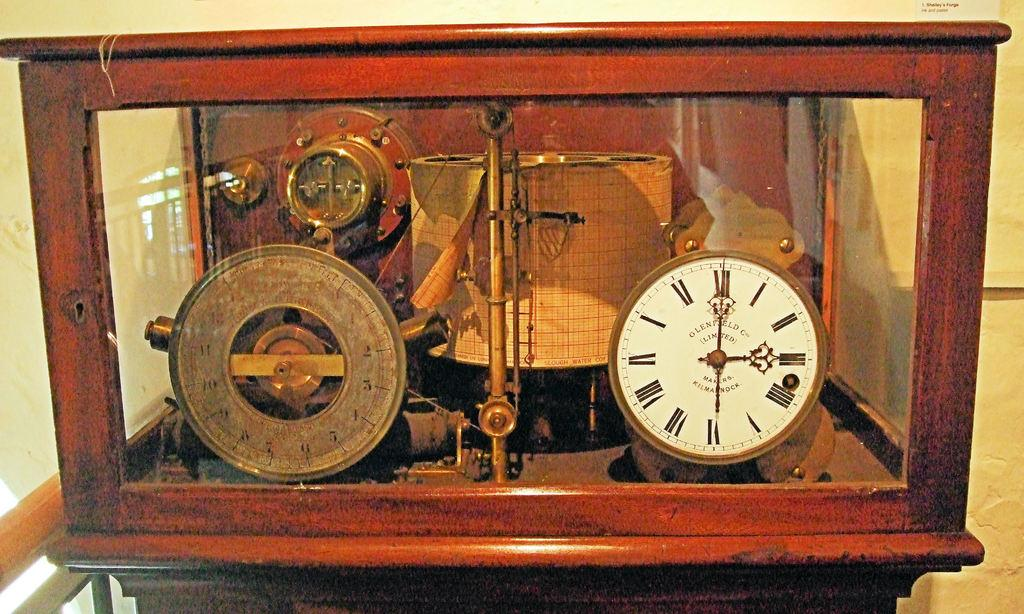<image>
Summarize the visual content of the image. An old fashioned clock in a wooden and glass box with watch face that says "Olenfield Co Limited." 